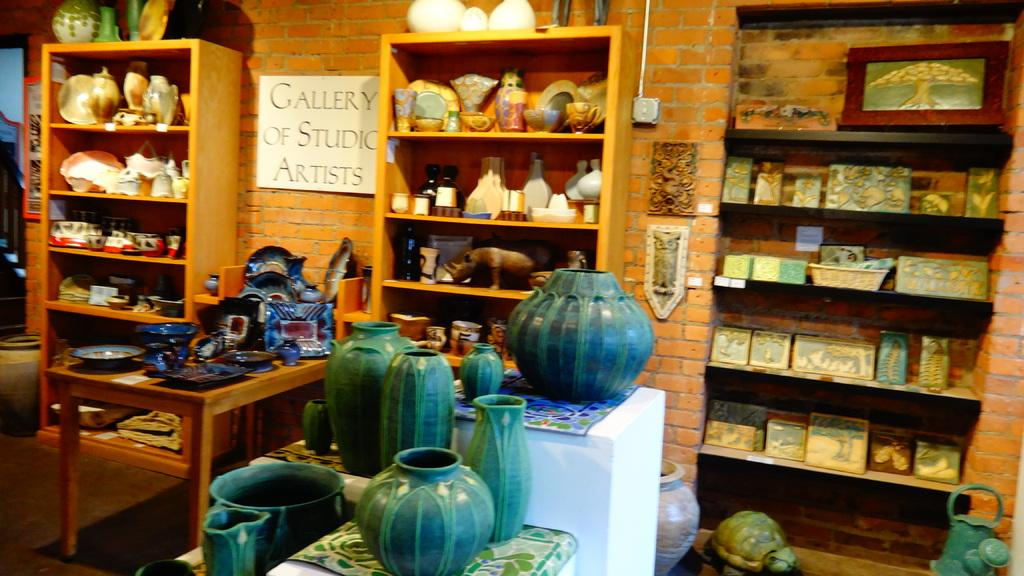<image>
Offer a succinct explanation of the picture presented. A gallery of pottery with a sign that says Gallery of Studio Artists. 